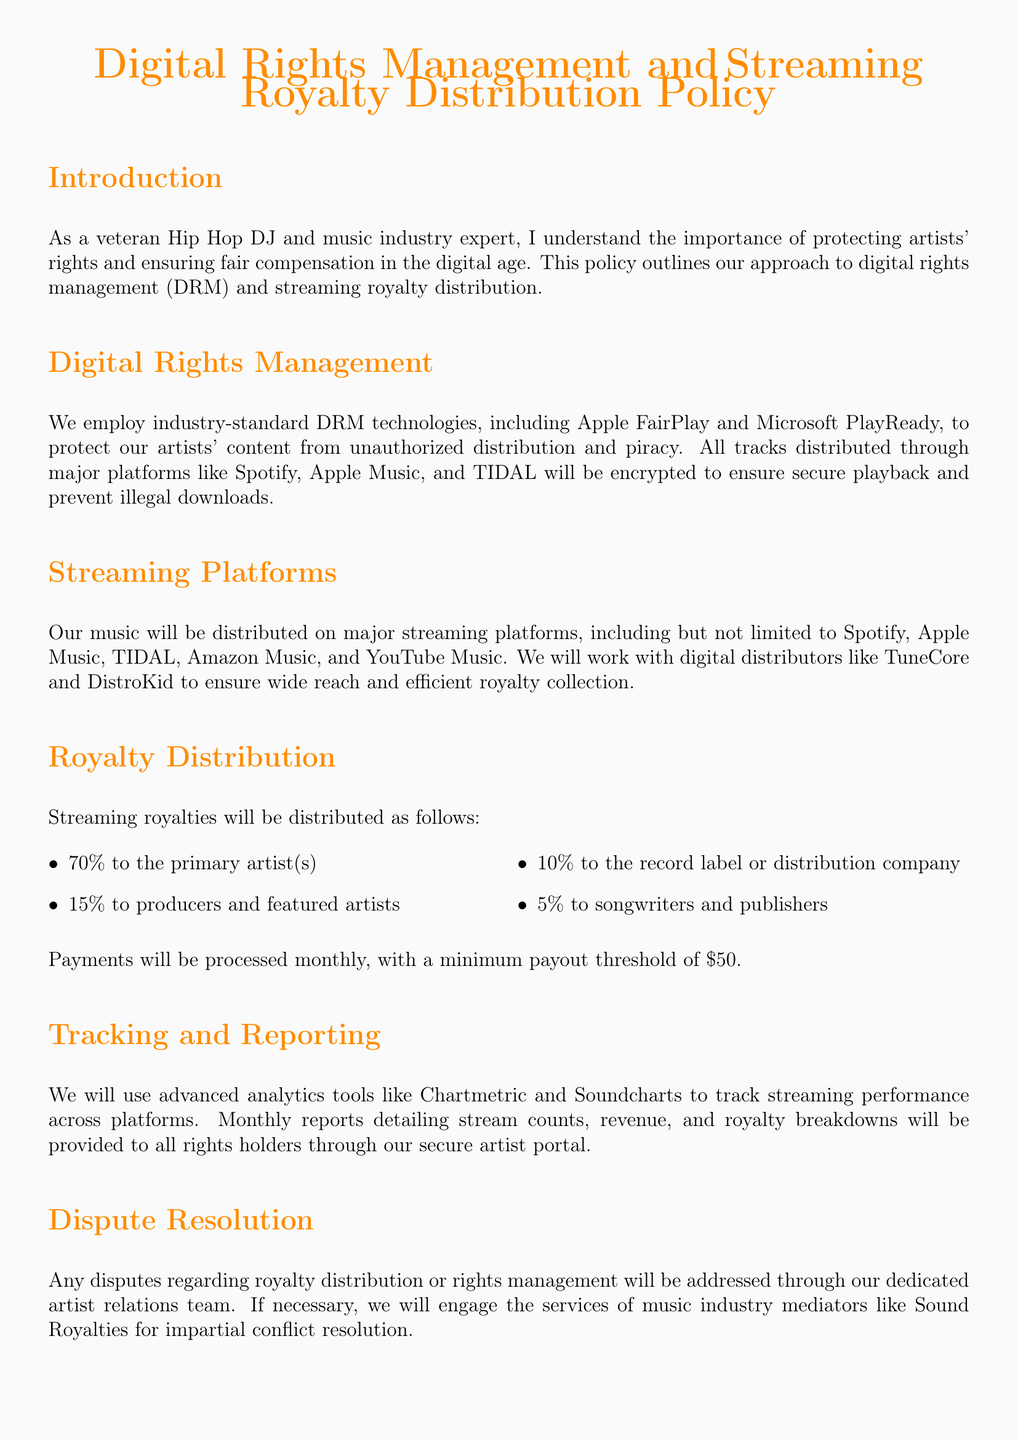What DRM technologies are used? The document lists Apple FairPlay and Microsoft PlayReady as the DRM technologies employed.
Answer: Apple FairPlay and Microsoft PlayReady What percentage of streaming royalties goes to the primary artist? The royalty distribution section specifically states that 70% of streaming royalties is allocated to the primary artist(s).
Answer: 70% What is the minimum payout threshold? The policy mentions a minimum payout threshold of $50 for payments.
Answer: $50 Which analytics tools are used for tracking? Advanced analytics tools mentioned for tracking streaming performance are Chartmetric and Soundcharts.
Answer: Chartmetric and Soundcharts How much do songwriters and publishers receive from royalties? The document specifies that songwriters and publishers receive 5% of the streaming royalties.
Answer: 5% What is the processing frequency for royalty payments? The document states that payments will be processed monthly.
Answer: Monthly Who handles disputes regarding royalty distribution? The document mentions a dedicated artist relations team for addressing disputes.
Answer: Artist relations team What platforms will the music be distributed on? The document lists major platforms including Spotify, Apple Music, TIDAL, Amazon Music, and YouTube Music for distribution.
Answer: Spotify, Apple Music, TIDAL, Amazon Music, YouTube Music 